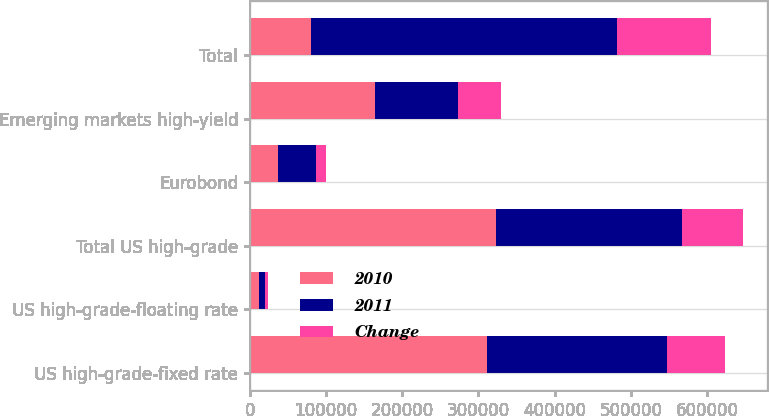<chart> <loc_0><loc_0><loc_500><loc_500><stacked_bar_chart><ecel><fcel>US high-grade-fixed rate<fcel>US high-grade-floating rate<fcel>Total US high-grade<fcel>Eurobond<fcel>Emerging markets high-yield<fcel>Total<nl><fcel>2010<fcel>311758<fcel>11802<fcel>323560<fcel>36933<fcel>164514<fcel>80164<nl><fcel>2011<fcel>235698<fcel>7698<fcel>243396<fcel>50251<fcel>108610<fcel>402257<nl><fcel>Change<fcel>76060<fcel>4104<fcel>80164<fcel>13318<fcel>55904<fcel>122750<nl></chart> 